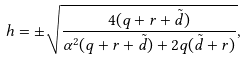Convert formula to latex. <formula><loc_0><loc_0><loc_500><loc_500>h = \pm \sqrt { \frac { 4 ( q + r + \tilde { d } ) } { \alpha ^ { 2 } ( q + r + \tilde { d } ) + 2 q ( \tilde { d } + r ) } } ,</formula> 